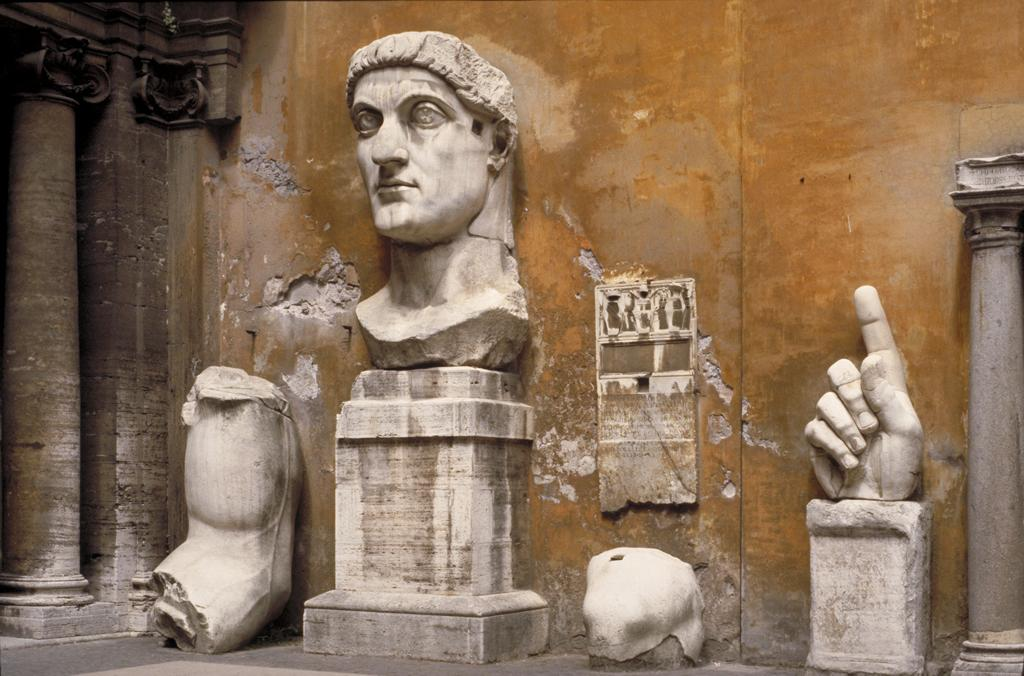What is the main object on the wall in the image? The fact does not specify the object on the wall, so we cannot answer this question definitively. What type of figures can be seen in the image? There are statues in the image. What architectural elements are present in the image? There are pillars in the image. What color can be observed in the image? There are white colored objects in the image. What is visible beneath the objects in the image? The ground is visible in the image. Can you see a ladybug crawling on the seashore in the image? There is no seashore or ladybug present in the image. 